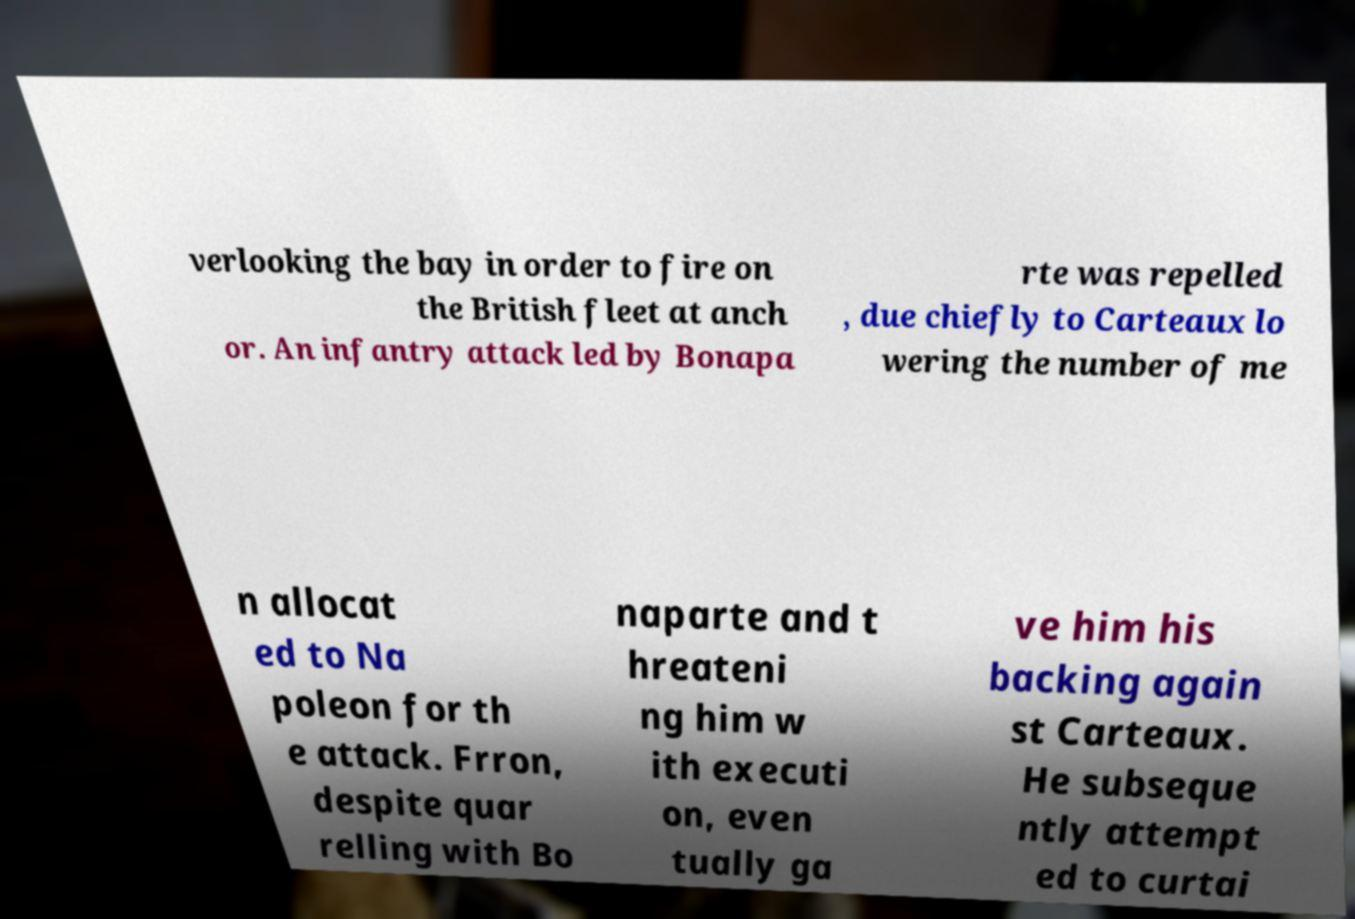What messages or text are displayed in this image? I need them in a readable, typed format. verlooking the bay in order to fire on the British fleet at anch or. An infantry attack led by Bonapa rte was repelled , due chiefly to Carteaux lo wering the number of me n allocat ed to Na poleon for th e attack. Frron, despite quar relling with Bo naparte and t hreateni ng him w ith executi on, even tually ga ve him his backing again st Carteaux. He subseque ntly attempt ed to curtai 